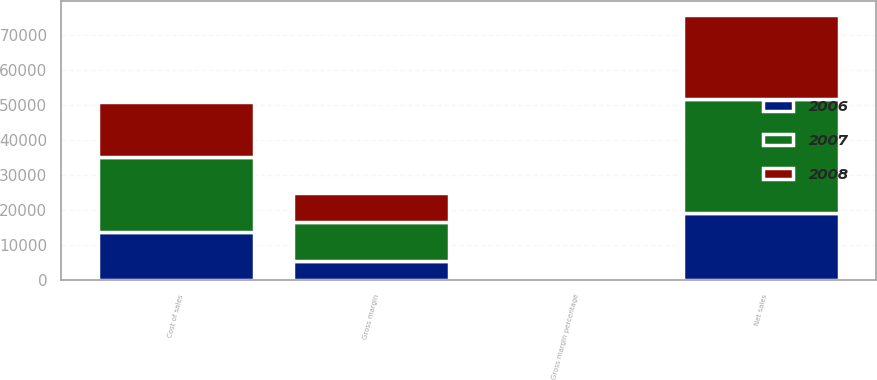Convert chart to OTSL. <chart><loc_0><loc_0><loc_500><loc_500><stacked_bar_chart><ecel><fcel>Net sales<fcel>Cost of sales<fcel>Gross margin<fcel>Gross margin percentage<nl><fcel>2007<fcel>32479<fcel>21334<fcel>11145<fcel>34.3<nl><fcel>2008<fcel>24006<fcel>15852<fcel>8154<fcel>34<nl><fcel>2006<fcel>19315<fcel>13717<fcel>5598<fcel>29<nl></chart> 